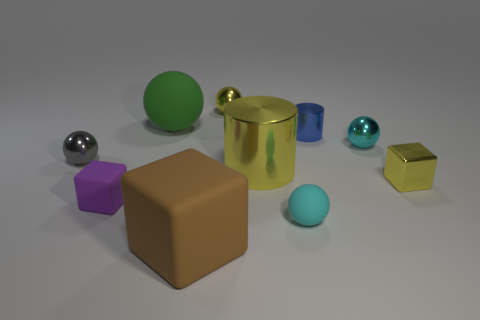Subtract all gray spheres. How many spheres are left? 4 Subtract 3 cubes. How many cubes are left? 0 Subtract all blue cylinders. How many blue balls are left? 0 Subtract all cyan metal balls. Subtract all tiny yellow metallic cubes. How many objects are left? 8 Add 7 tiny rubber blocks. How many tiny rubber blocks are left? 8 Add 3 cyan cylinders. How many cyan cylinders exist? 3 Subtract all yellow cubes. How many cubes are left? 2 Subtract 0 green cylinders. How many objects are left? 10 Subtract all cylinders. How many objects are left? 8 Subtract all brown blocks. Subtract all green cylinders. How many blocks are left? 2 